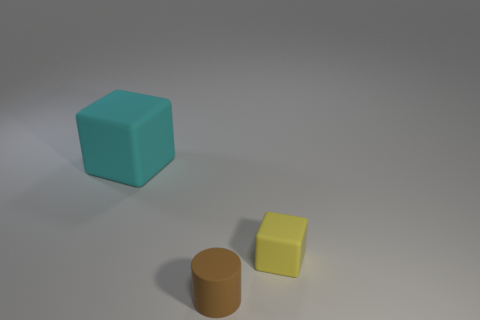Add 3 yellow blocks. How many objects exist? 6 Subtract all yellow blocks. How many blocks are left? 1 Subtract all cubes. How many objects are left? 1 Subtract 1 cubes. How many cubes are left? 1 Subtract all small brown matte things. Subtract all small matte objects. How many objects are left? 0 Add 1 brown objects. How many brown objects are left? 2 Add 1 cyan rubber blocks. How many cyan rubber blocks exist? 2 Subtract 0 purple cylinders. How many objects are left? 3 Subtract all yellow cylinders. Subtract all purple cubes. How many cylinders are left? 1 Subtract all green cylinders. How many yellow blocks are left? 1 